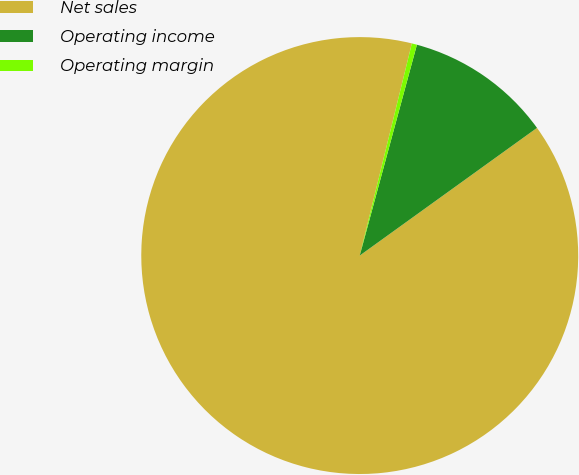Convert chart to OTSL. <chart><loc_0><loc_0><loc_500><loc_500><pie_chart><fcel>Net sales<fcel>Operating income<fcel>Operating margin<nl><fcel>88.77%<fcel>10.85%<fcel>0.38%<nl></chart> 